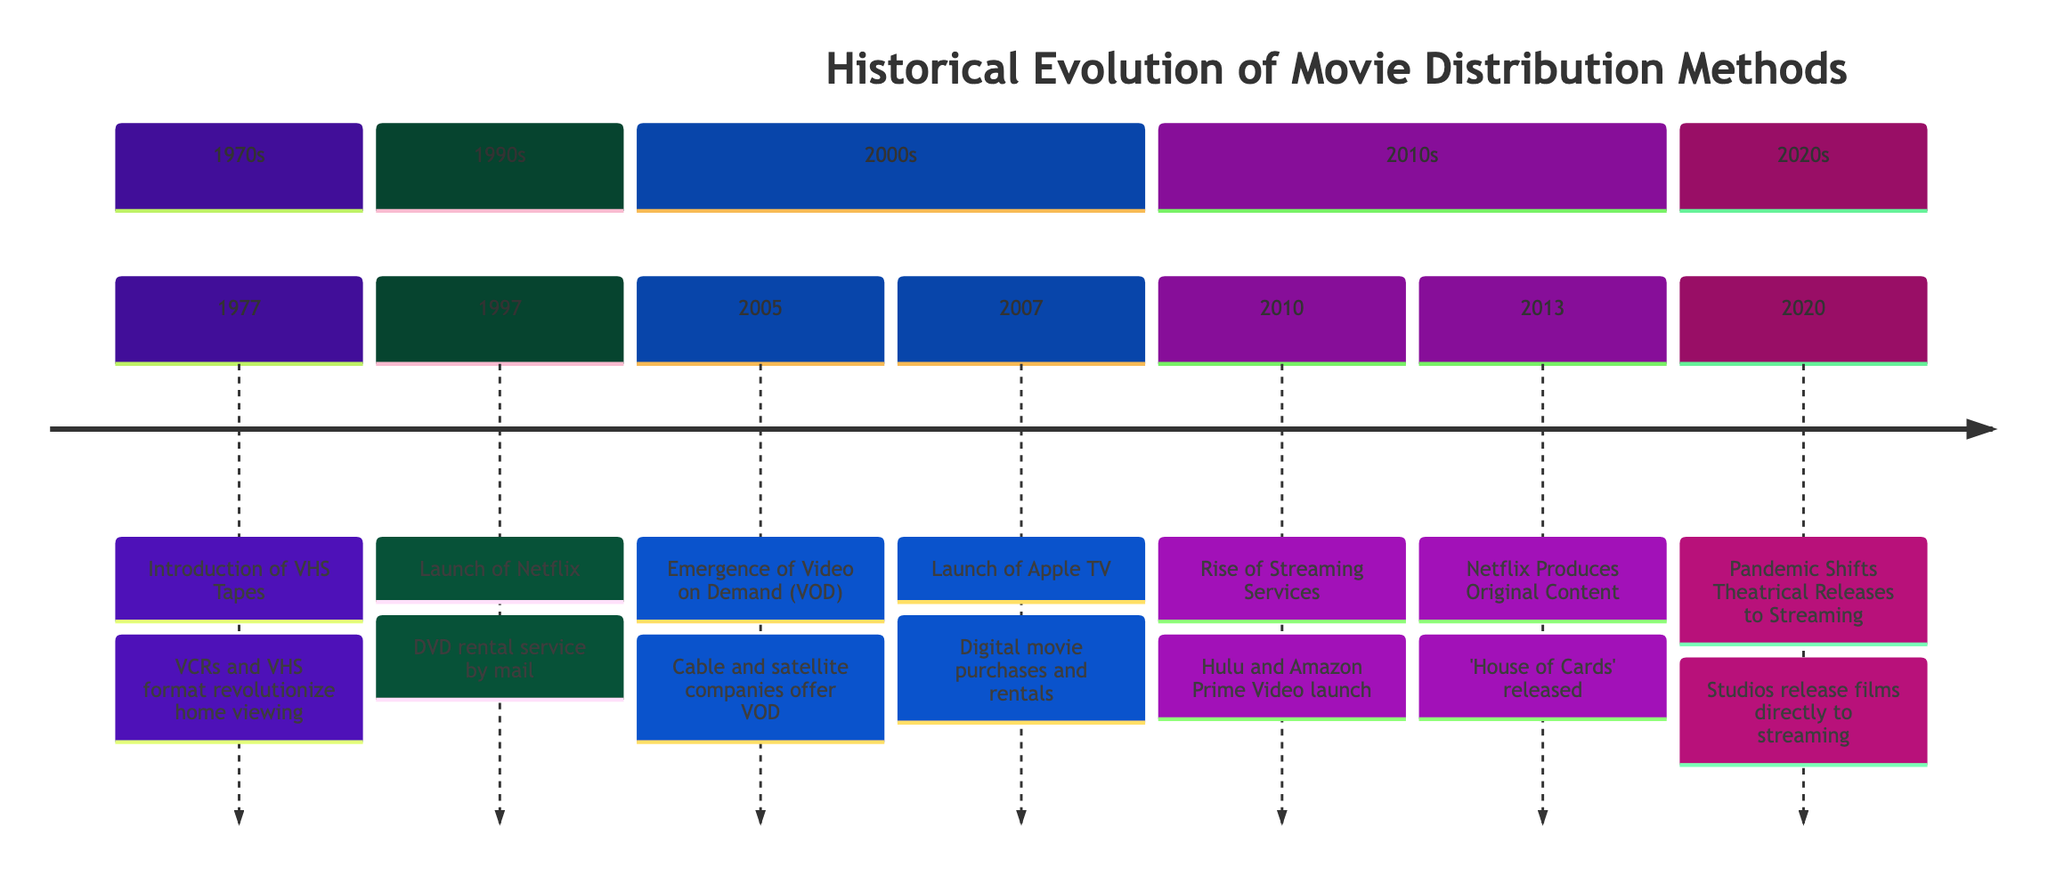What year was the introduction of VHS Tapes? The diagram shows that the event "Introduction of VHS Tapes" occurred in the year 1977, which is indicated directly on the timeline next to the event description.
Answer: 1977 How many significant events are shown in the timeline? By counting the listed events on the timeline, there are a total of 7 events displayed, each representing a significant milestone in movie distribution methods.
Answer: 7 What event occurred in 2010? The diagram indicates that in the year 2010, the event "Rise of Streaming Services" took place, marking an important shift in distribution methods.
Answer: Rise of Streaming Services In which decade did Netflix begin as a DVD rental service? The timeline indicates that Netflix launched as a DVD rental service in 1997, which is within the 1990s decade.
Answer: 1990s What event marked a shift to streaming due to the pandemic? The timeline shows the event "Theatrical Releases Shift to Streaming Due to Pandemic" occurring in 2020, which signifies a notable transition in movie distribution strategies.
Answer: Theatrical Releases Shift to Streaming Due to Pandemic Which event directly preceded the emergence of Video on Demand (VOD)? The timeline lists the event "Launch of Netflix" in 1997, and "Emergence of Video on Demand (VOD)" occurred in 2005, so Netflix's launch directly precedes VOD.
Answer: Launch of Netflix What is the main impact of Netflix producing original content in 2013? The diagram states that Netflix producing "House of Cards" in 2013 changed content distribution and consumption, highlighting that it had a transformative effect on the industry.
Answer: Changed content distribution and consumption How did the launch of Apple TV contribute to movie distribution? The timeline indicates that Apple TV's launch in 2007 facilitated digital movie purchases and rentals directly from a device, marking a crucial step towards digital media consumption.
Answer: Digital movie purchases and rentals 